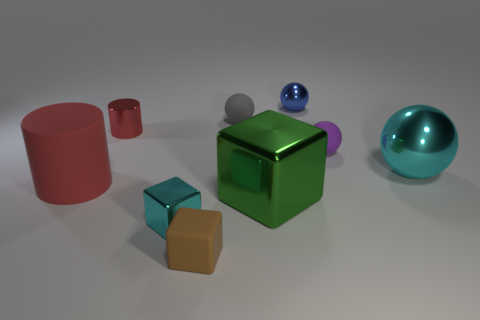Are the cylinder in front of the small cylinder and the tiny ball that is in front of the red metallic thing made of the same material?
Make the answer very short. Yes. The purple thing that is the same material as the large red thing is what shape?
Your response must be concise. Sphere. Are there any other things that have the same color as the large rubber object?
Make the answer very short. Yes. What number of gray spheres are there?
Your answer should be compact. 1. What is the material of the cylinder behind the cylinder that is in front of the big cyan sphere?
Give a very brief answer. Metal. What color is the rubber thing to the right of the metallic sphere behind the big metal object behind the large cube?
Make the answer very short. Purple. Does the tiny metal ball have the same color as the tiny shiny cylinder?
Give a very brief answer. No. What number of other blocks are the same size as the cyan cube?
Provide a short and direct response. 1. Are there more matte things behind the large cyan thing than large green metal blocks on the left side of the brown rubber thing?
Your answer should be very brief. Yes. There is a small metal thing in front of the metal sphere to the right of the small blue metal object; what is its color?
Your answer should be compact. Cyan. 